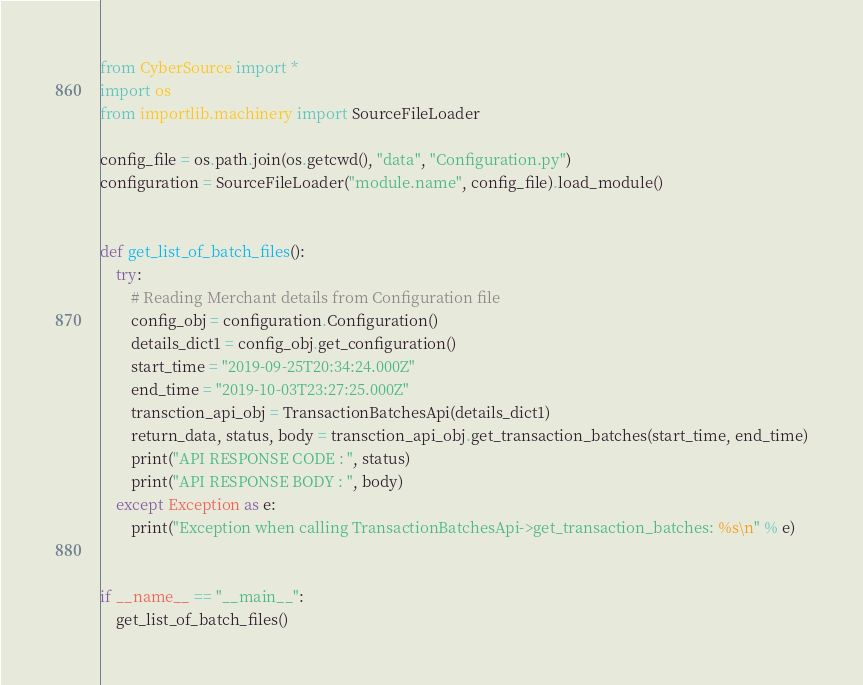<code> <loc_0><loc_0><loc_500><loc_500><_Python_>from CyberSource import *
import os
from importlib.machinery import SourceFileLoader

config_file = os.path.join(os.getcwd(), "data", "Configuration.py")
configuration = SourceFileLoader("module.name", config_file).load_module()


def get_list_of_batch_files():
    try:
        # Reading Merchant details from Configuration file
        config_obj = configuration.Configuration()
        details_dict1 = config_obj.get_configuration()
        start_time = "2019-09-25T20:34:24.000Z"
        end_time = "2019-10-03T23:27:25.000Z"
        transction_api_obj = TransactionBatchesApi(details_dict1)
        return_data, status, body = transction_api_obj.get_transaction_batches(start_time, end_time)
        print("API RESPONSE CODE : ", status)
        print("API RESPONSE BODY : ", body)
    except Exception as e:
        print("Exception when calling TransactionBatchesApi->get_transaction_batches: %s\n" % e)


if __name__ == "__main__":
    get_list_of_batch_files()
</code> 